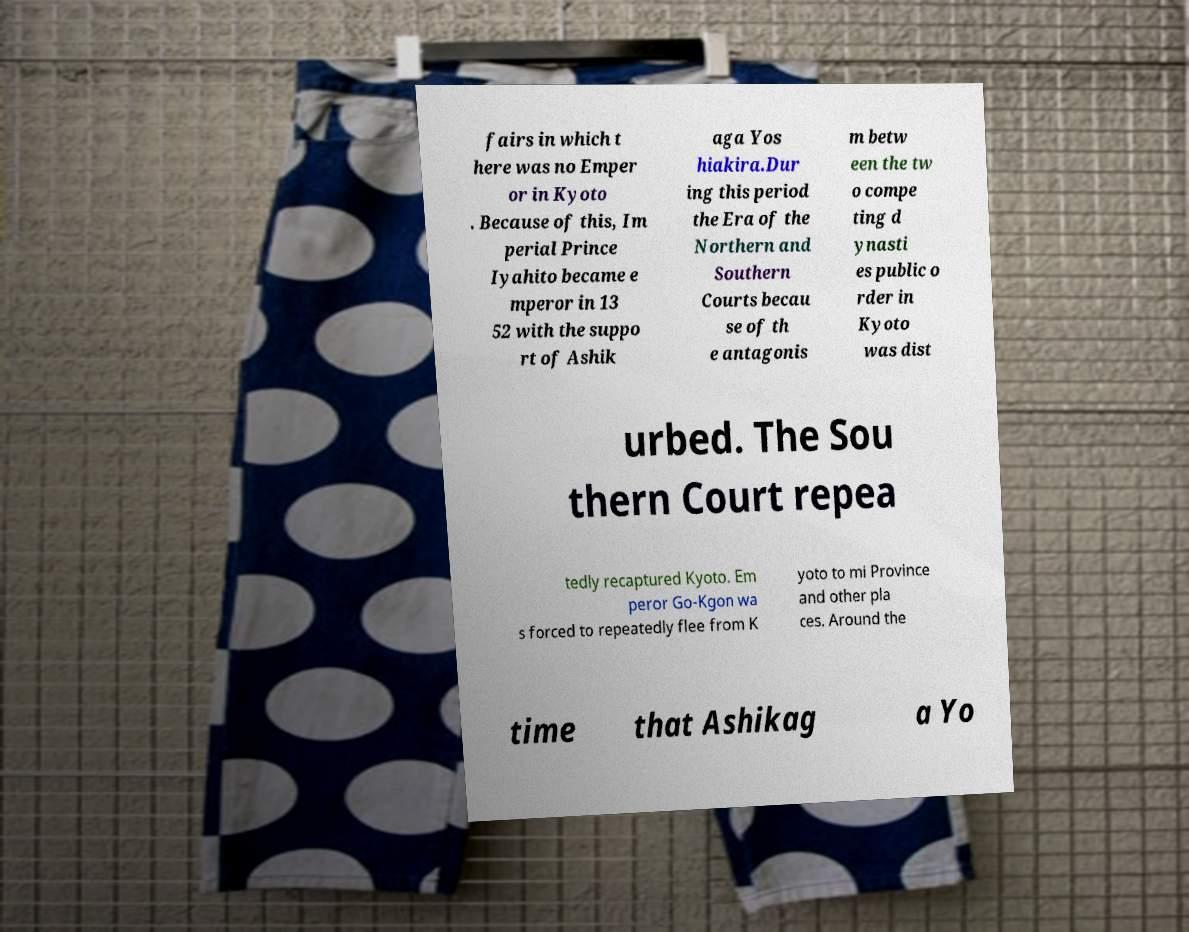There's text embedded in this image that I need extracted. Can you transcribe it verbatim? fairs in which t here was no Emper or in Kyoto . Because of this, Im perial Prince Iyahito became e mperor in 13 52 with the suppo rt of Ashik aga Yos hiakira.Dur ing this period the Era of the Northern and Southern Courts becau se of th e antagonis m betw een the tw o compe ting d ynasti es public o rder in Kyoto was dist urbed. The Sou thern Court repea tedly recaptured Kyoto. Em peror Go-Kgon wa s forced to repeatedly flee from K yoto to mi Province and other pla ces. Around the time that Ashikag a Yo 